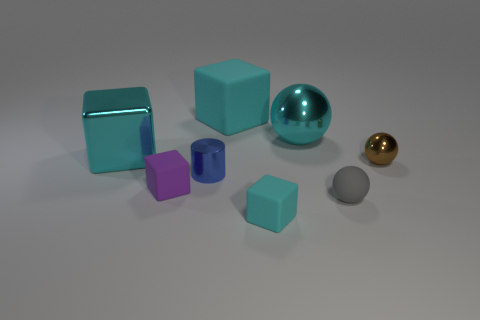Subtract all cyan blocks. How many were subtracted if there are1cyan blocks left? 2 Subtract all cyan cylinders. How many cyan cubes are left? 3 Subtract all metal cubes. How many cubes are left? 3 Add 1 brown metal objects. How many objects exist? 9 Subtract all purple blocks. How many blocks are left? 3 Subtract all yellow cubes. Subtract all purple spheres. How many cubes are left? 4 Subtract all cylinders. How many objects are left? 7 Add 1 cyan blocks. How many cyan blocks exist? 4 Subtract 0 green cylinders. How many objects are left? 8 Subtract all gray rubber objects. Subtract all tiny gray objects. How many objects are left? 6 